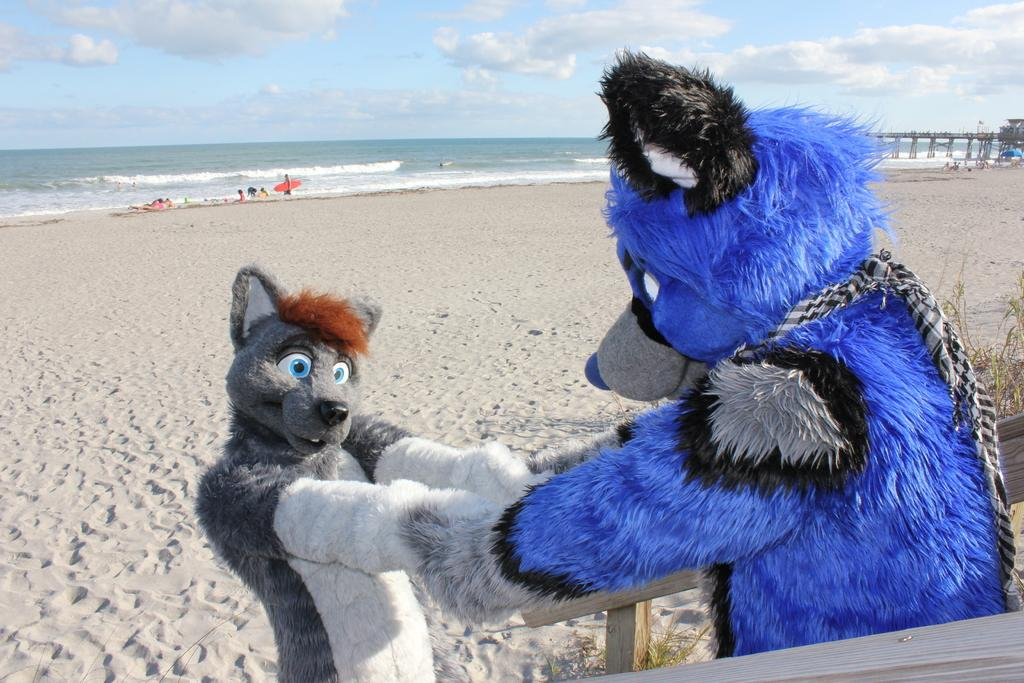What type of objects can be seen in the image? There are toys in the image. What material is present in the image? There is sand in the image. What structure is visible in the image? There is a bridge in the image. Who or what is present in the image? There are people in the image. What can be seen in the background of the image? There is water and sky visible in the background of the image. What is the condition of the sky in the image? There are clouds in the sky. What type of art can be seen on the bridge in the image? There is no art present on the bridge in the image; it is a structure for crossing water. How many parcels are being delivered by the people in the image? There is no mention of parcels or deliveries in the image; it features toys, sand, a bridge, and people. 